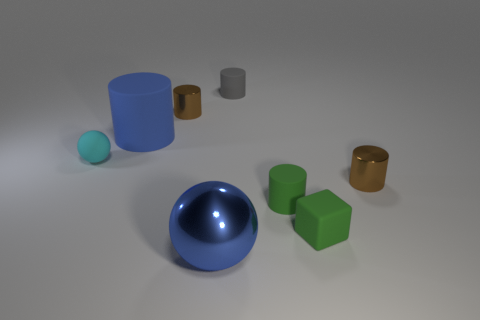What size is the blue ball?
Your answer should be very brief. Large. There is a brown metal thing that is in front of the blue rubber object; how big is it?
Give a very brief answer. Small. Do the metal cylinder on the right side of the green rubber block and the small rubber ball have the same size?
Make the answer very short. Yes. Are there any other things that are the same color as the metal sphere?
Ensure brevity in your answer.  Yes. What shape is the cyan matte object?
Your answer should be very brief. Sphere. How many tiny cylinders are on the right side of the small cube and left of the small green matte cylinder?
Give a very brief answer. 0. Is the color of the large matte thing the same as the large shiny ball?
Your answer should be very brief. Yes. What material is the small green object that is the same shape as the tiny gray matte thing?
Give a very brief answer. Rubber. Are there any other things that have the same material as the small cyan thing?
Ensure brevity in your answer.  Yes. Are there an equal number of small cyan things in front of the small cyan thing and tiny cyan spheres that are in front of the big shiny thing?
Offer a terse response. Yes. 